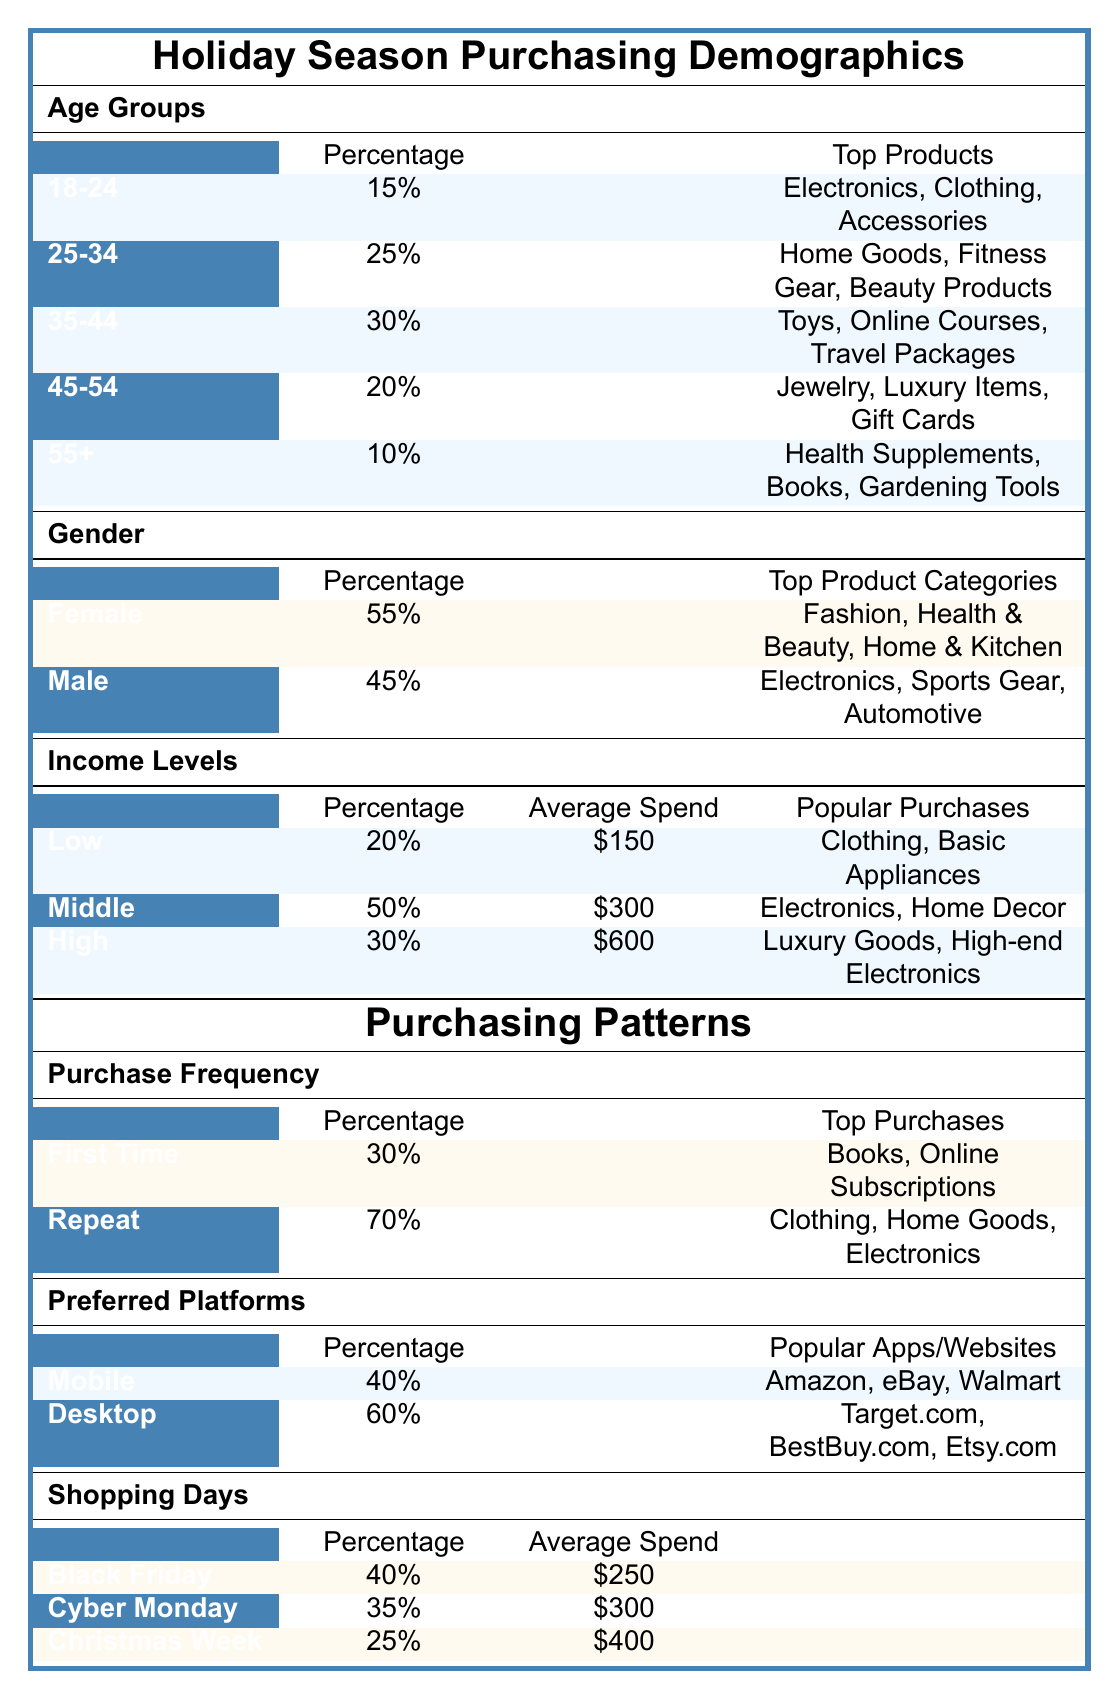What percentage of online retail purchases during the holiday season are made by customers aged 35-44? According to the table, the percentage of online retail purchases made by customers aged 35-44 is listed as 30%.
Answer: 30% Which age group spends the most on average? The high-income age group is noted as spending an average of $600, whereas middle-income spends $300 and low-income spends $150. Therefore, the age group associated with high income is the one that spends the most.
Answer: 35-44 What are the top product categories purchased by female customers? The table states that female customers have a percentage of 55% and their top product categories are Fashion, Health & Beauty, and Home & Kitchen.
Answer: Fashion, Health & Beauty, Home & Kitchen Is it true that more people prefer to shop on mobile than on desktop? According to the data, 40% prefer mobile shopping, while 60% prefer desktop. Therefore, it is false that more people prefer mobile shopping.
Answer: No What is the total percentage of purchases made by customers aged 18-34? To find the total percentage, add the percentages of age groups 18-24 (15%) and 25-34 (25%). The total is 15% + 25% = 40%.
Answer: 40% How much do customers typically spend during Christmas week? From the table, it shows that the average spend during Christmas week is listed as $400.
Answer: $400 What percentage of first-time buyers purchase books? The table indicates that first-time buyers make up 30% of purchases, but it does not specify a percentage for those who purchase books among them. It only lists books as a top purchase.
Answer: No specific percentage given How does the average spend of high income compare to low income? High-income earners have an average spend of $600 while low-income earners have an average spend of $150. Therefore, high income spends more and the difference is $600 - $150 = $450.
Answer: $450 more Which shopping day has the highest average spend? Among Black Friday ($250), Cyber Monday ($300), and Christmas week ($400), the day with the highest average spend is Christmas week, noted as $400.
Answer: Christmas week 